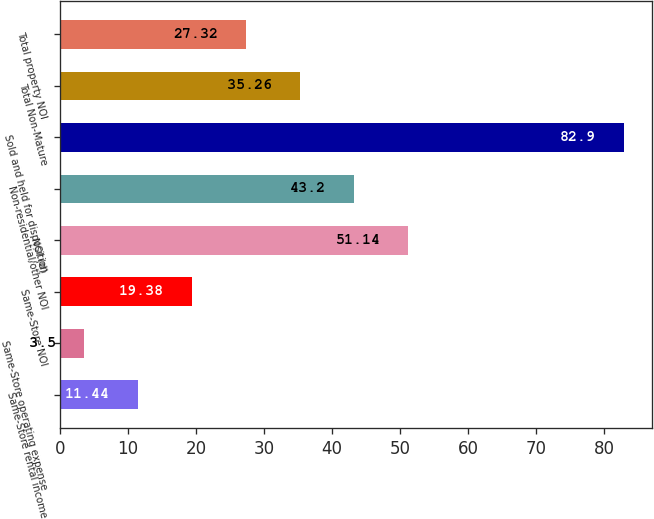Convert chart to OTSL. <chart><loc_0><loc_0><loc_500><loc_500><bar_chart><fcel>Same-Store rental income<fcel>Same-Store operating expense<fcel>Same-Store NOI<fcel>NOI (d)<fcel>Non-residential/other NOI<fcel>Sold and held for disposition<fcel>Total Non-Mature<fcel>Total property NOI<nl><fcel>11.44<fcel>3.5<fcel>19.38<fcel>51.14<fcel>43.2<fcel>82.9<fcel>35.26<fcel>27.32<nl></chart> 